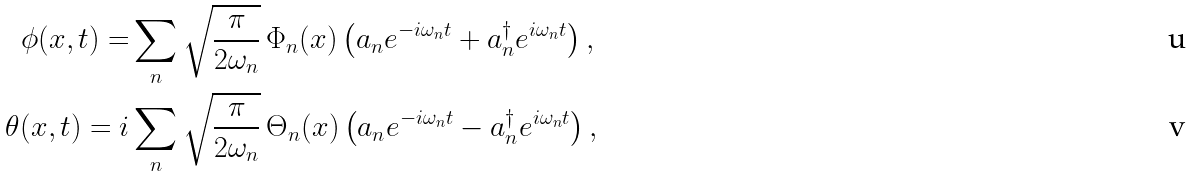Convert formula to latex. <formula><loc_0><loc_0><loc_500><loc_500>\phi ( x , t ) = & \sum _ { n } \sqrt { \frac { \pi } { 2 \omega _ { n } } } \, \Phi _ { n } ( x ) \left ( a _ { n } e ^ { - i \omega _ { n } t } + a ^ { \dagger } _ { n } e ^ { i \omega _ { n } t } \right ) , \\ \theta ( x , t ) = i & \sum _ { n } \sqrt { \frac { \pi } { 2 \omega _ { n } } } \, \Theta _ { n } ( x ) \left ( a _ { n } e ^ { - i \omega _ { n } t } - a ^ { \dagger } _ { n } e ^ { i \omega _ { n } t } \right ) ,</formula> 